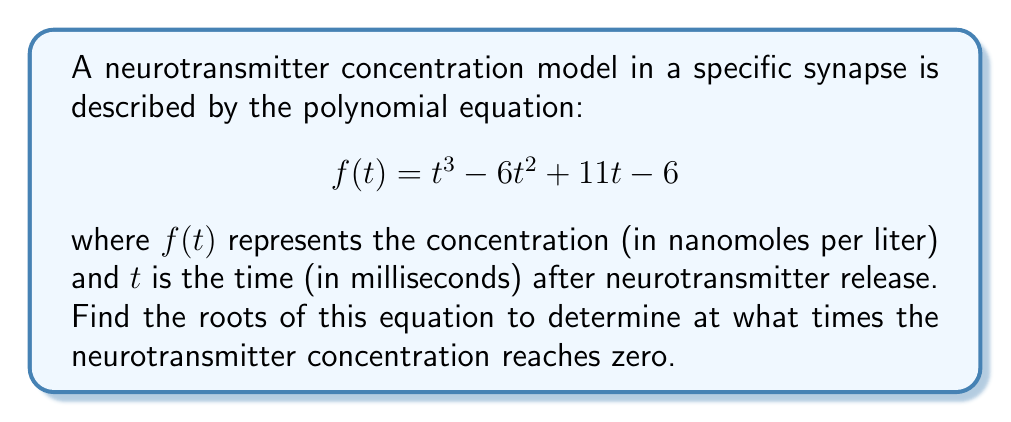Give your solution to this math problem. To find the roots of the polynomial equation, we need to solve:

$$t^3 - 6t^2 + 11t - 6 = 0$$

Let's approach this step-by-step:

1) First, we can try to factor out a common factor:
   There's no common factor for all terms.

2) Next, let's check if we can use the rational root theorem:
   The possible rational roots are the factors of the constant term (6): ±1, ±2, ±3, ±6

3) Let's test these values:
   $f(1) = 1 - 6 + 11 - 6 = 0$
   We found one root: $t = 1$

4) Now we can factor out $(t-1)$:
   $t^3 - 6t^2 + 11t - 6 = (t-1)(t^2 - 5t + 6)$

5) We can solve the quadratic equation $t^2 - 5t + 6 = 0$ using the quadratic formula:
   $t = \frac{-b \pm \sqrt{b^2 - 4ac}}{2a}$
   
   Here, $a=1$, $b=-5$, and $c=6$

   $t = \frac{5 \pm \sqrt{25 - 24}}{2} = \frac{5 \pm 1}{2}$

6) This gives us two more roots:
   $t = \frac{5 + 1}{2} = 3$ and $t = \frac{5 - 1}{2} = 2$

Therefore, the roots of the equation are 1, 2, and 3.
Answer: $t = 1, 2, 3$ ms 